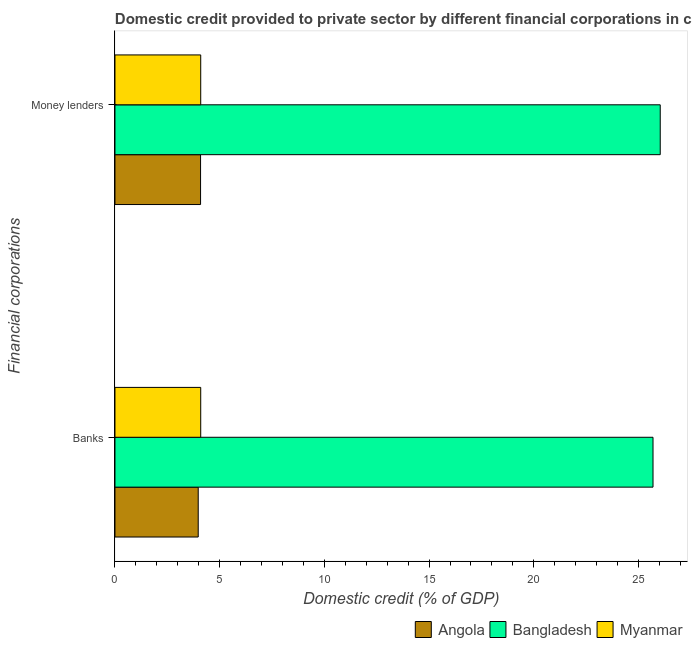How many different coloured bars are there?
Your answer should be compact. 3. Are the number of bars on each tick of the Y-axis equal?
Your response must be concise. Yes. How many bars are there on the 2nd tick from the top?
Make the answer very short. 3. How many bars are there on the 2nd tick from the bottom?
Provide a short and direct response. 3. What is the label of the 1st group of bars from the top?
Offer a terse response. Money lenders. What is the domestic credit provided by banks in Bangladesh?
Your answer should be very brief. 25.69. Across all countries, what is the maximum domestic credit provided by money lenders?
Your answer should be very brief. 26.04. Across all countries, what is the minimum domestic credit provided by banks?
Offer a terse response. 3.98. In which country was the domestic credit provided by banks maximum?
Offer a terse response. Bangladesh. In which country was the domestic credit provided by money lenders minimum?
Your response must be concise. Angola. What is the total domestic credit provided by banks in the graph?
Ensure brevity in your answer.  33.77. What is the difference between the domestic credit provided by banks in Myanmar and that in Angola?
Make the answer very short. 0.12. What is the difference between the domestic credit provided by money lenders in Angola and the domestic credit provided by banks in Myanmar?
Provide a short and direct response. -0.01. What is the average domestic credit provided by money lenders per country?
Your response must be concise. 11.41. What is the difference between the domestic credit provided by banks and domestic credit provided by money lenders in Angola?
Offer a terse response. -0.11. In how many countries, is the domestic credit provided by money lenders greater than 16 %?
Provide a short and direct response. 1. What is the ratio of the domestic credit provided by money lenders in Myanmar to that in Angola?
Your answer should be very brief. 1. Is the domestic credit provided by banks in Myanmar less than that in Bangladesh?
Give a very brief answer. Yes. What does the 1st bar from the top in Money lenders represents?
Keep it short and to the point. Myanmar. What does the 2nd bar from the bottom in Banks represents?
Provide a short and direct response. Bangladesh. Are all the bars in the graph horizontal?
Your answer should be compact. Yes. Are the values on the major ticks of X-axis written in scientific E-notation?
Provide a succinct answer. No. What is the title of the graph?
Your response must be concise. Domestic credit provided to private sector by different financial corporations in countries. Does "Bangladesh" appear as one of the legend labels in the graph?
Give a very brief answer. Yes. What is the label or title of the X-axis?
Your answer should be very brief. Domestic credit (% of GDP). What is the label or title of the Y-axis?
Your response must be concise. Financial corporations. What is the Domestic credit (% of GDP) in Angola in Banks?
Provide a short and direct response. 3.98. What is the Domestic credit (% of GDP) in Bangladesh in Banks?
Make the answer very short. 25.69. What is the Domestic credit (% of GDP) in Myanmar in Banks?
Provide a short and direct response. 4.1. What is the Domestic credit (% of GDP) of Angola in Money lenders?
Offer a terse response. 4.09. What is the Domestic credit (% of GDP) in Bangladesh in Money lenders?
Give a very brief answer. 26.04. What is the Domestic credit (% of GDP) in Myanmar in Money lenders?
Keep it short and to the point. 4.1. Across all Financial corporations, what is the maximum Domestic credit (% of GDP) of Angola?
Ensure brevity in your answer.  4.09. Across all Financial corporations, what is the maximum Domestic credit (% of GDP) of Bangladesh?
Keep it short and to the point. 26.04. Across all Financial corporations, what is the maximum Domestic credit (% of GDP) in Myanmar?
Ensure brevity in your answer.  4.1. Across all Financial corporations, what is the minimum Domestic credit (% of GDP) of Angola?
Make the answer very short. 3.98. Across all Financial corporations, what is the minimum Domestic credit (% of GDP) in Bangladesh?
Offer a terse response. 25.69. Across all Financial corporations, what is the minimum Domestic credit (% of GDP) in Myanmar?
Your response must be concise. 4.1. What is the total Domestic credit (% of GDP) of Angola in the graph?
Your response must be concise. 8.06. What is the total Domestic credit (% of GDP) of Bangladesh in the graph?
Your answer should be compact. 51.73. What is the total Domestic credit (% of GDP) in Myanmar in the graph?
Ensure brevity in your answer.  8.19. What is the difference between the Domestic credit (% of GDP) in Angola in Banks and that in Money lenders?
Your response must be concise. -0.11. What is the difference between the Domestic credit (% of GDP) in Bangladesh in Banks and that in Money lenders?
Provide a short and direct response. -0.34. What is the difference between the Domestic credit (% of GDP) in Myanmar in Banks and that in Money lenders?
Keep it short and to the point. 0. What is the difference between the Domestic credit (% of GDP) in Angola in Banks and the Domestic credit (% of GDP) in Bangladesh in Money lenders?
Keep it short and to the point. -22.06. What is the difference between the Domestic credit (% of GDP) of Angola in Banks and the Domestic credit (% of GDP) of Myanmar in Money lenders?
Make the answer very short. -0.12. What is the difference between the Domestic credit (% of GDP) of Bangladesh in Banks and the Domestic credit (% of GDP) of Myanmar in Money lenders?
Keep it short and to the point. 21.6. What is the average Domestic credit (% of GDP) of Angola per Financial corporations?
Keep it short and to the point. 4.03. What is the average Domestic credit (% of GDP) in Bangladesh per Financial corporations?
Your response must be concise. 25.87. What is the average Domestic credit (% of GDP) in Myanmar per Financial corporations?
Keep it short and to the point. 4.1. What is the difference between the Domestic credit (% of GDP) in Angola and Domestic credit (% of GDP) in Bangladesh in Banks?
Your answer should be compact. -21.72. What is the difference between the Domestic credit (% of GDP) of Angola and Domestic credit (% of GDP) of Myanmar in Banks?
Provide a succinct answer. -0.12. What is the difference between the Domestic credit (% of GDP) in Bangladesh and Domestic credit (% of GDP) in Myanmar in Banks?
Your answer should be compact. 21.6. What is the difference between the Domestic credit (% of GDP) of Angola and Domestic credit (% of GDP) of Bangladesh in Money lenders?
Your answer should be compact. -21.95. What is the difference between the Domestic credit (% of GDP) in Angola and Domestic credit (% of GDP) in Myanmar in Money lenders?
Your response must be concise. -0.01. What is the difference between the Domestic credit (% of GDP) of Bangladesh and Domestic credit (% of GDP) of Myanmar in Money lenders?
Your response must be concise. 21.94. What is the ratio of the Domestic credit (% of GDP) of Angola in Banks to that in Money lenders?
Keep it short and to the point. 0.97. What is the difference between the highest and the second highest Domestic credit (% of GDP) in Angola?
Provide a succinct answer. 0.11. What is the difference between the highest and the second highest Domestic credit (% of GDP) in Bangladesh?
Your response must be concise. 0.34. What is the difference between the highest and the second highest Domestic credit (% of GDP) in Myanmar?
Keep it short and to the point. 0. What is the difference between the highest and the lowest Domestic credit (% of GDP) of Angola?
Offer a very short reply. 0.11. What is the difference between the highest and the lowest Domestic credit (% of GDP) in Bangladesh?
Offer a very short reply. 0.34. What is the difference between the highest and the lowest Domestic credit (% of GDP) in Myanmar?
Make the answer very short. 0. 